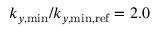<formula> <loc_0><loc_0><loc_500><loc_500>k _ { y , \min } / k _ { y , \min , r e f } = 2 . 0</formula> 